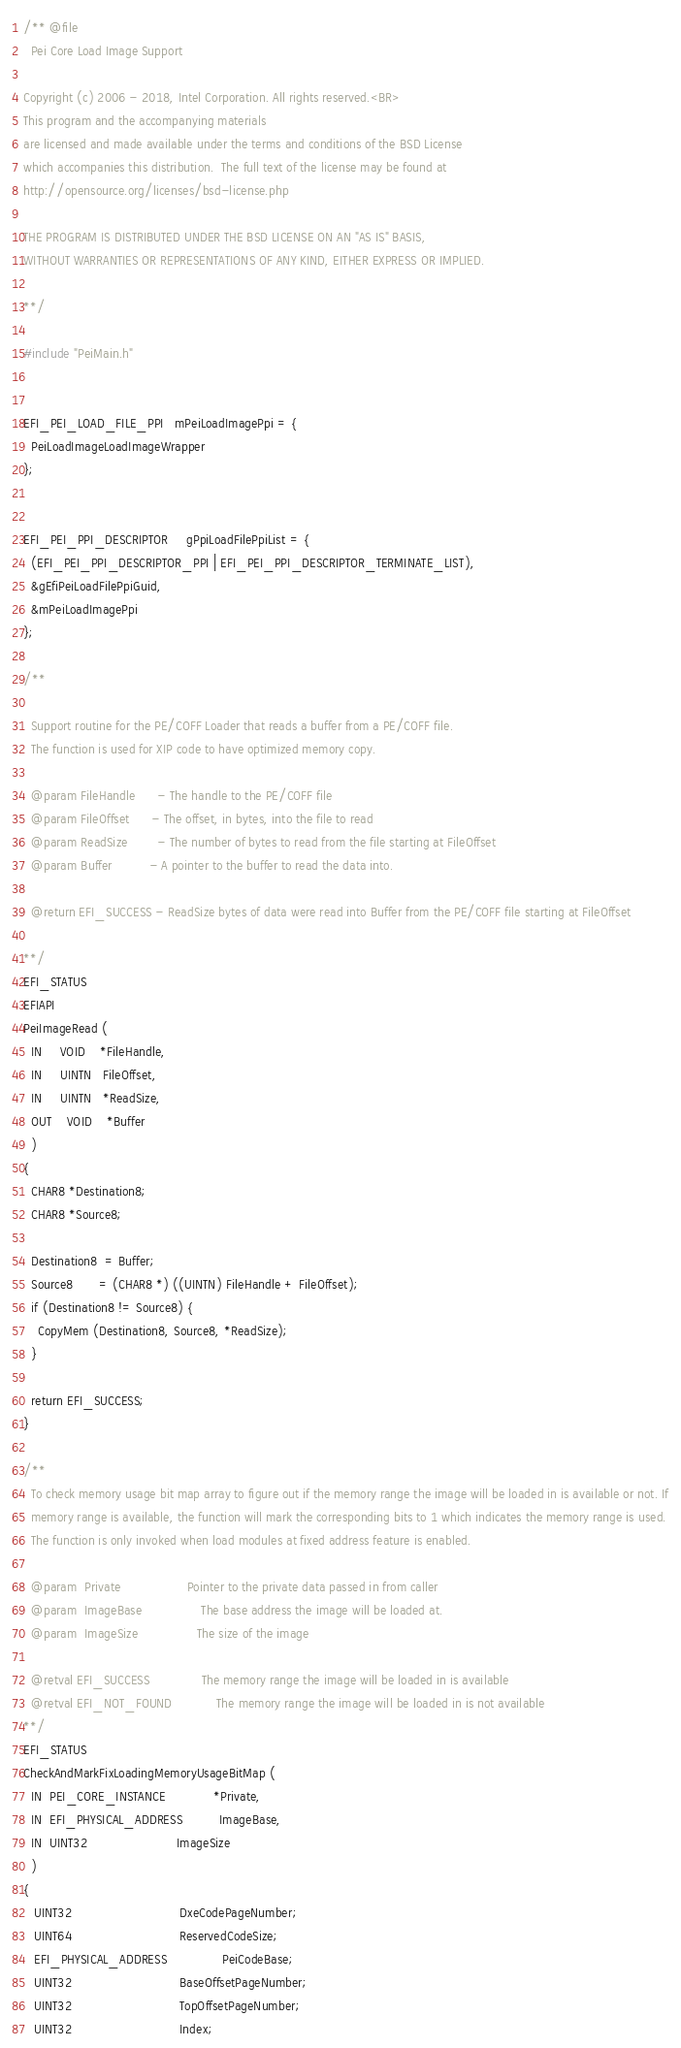Convert code to text. <code><loc_0><loc_0><loc_500><loc_500><_C_>/** @file
  Pei Core Load Image Support

Copyright (c) 2006 - 2018, Intel Corporation. All rights reserved.<BR>
This program and the accompanying materials
are licensed and made available under the terms and conditions of the BSD License
which accompanies this distribution.  The full text of the license may be found at
http://opensource.org/licenses/bsd-license.php

THE PROGRAM IS DISTRIBUTED UNDER THE BSD LICENSE ON AN "AS IS" BASIS,
WITHOUT WARRANTIES OR REPRESENTATIONS OF ANY KIND, EITHER EXPRESS OR IMPLIED.

**/

#include "PeiMain.h"


EFI_PEI_LOAD_FILE_PPI   mPeiLoadImagePpi = {
  PeiLoadImageLoadImageWrapper
};


EFI_PEI_PPI_DESCRIPTOR     gPpiLoadFilePpiList = {
  (EFI_PEI_PPI_DESCRIPTOR_PPI | EFI_PEI_PPI_DESCRIPTOR_TERMINATE_LIST),
  &gEfiPeiLoadFilePpiGuid,
  &mPeiLoadImagePpi
};

/**

  Support routine for the PE/COFF Loader that reads a buffer from a PE/COFF file.
  The function is used for XIP code to have optimized memory copy.

  @param FileHandle      - The handle to the PE/COFF file
  @param FileOffset      - The offset, in bytes, into the file to read
  @param ReadSize        - The number of bytes to read from the file starting at FileOffset
  @param Buffer          - A pointer to the buffer to read the data into.

  @return EFI_SUCCESS - ReadSize bytes of data were read into Buffer from the PE/COFF file starting at FileOffset

**/
EFI_STATUS
EFIAPI
PeiImageRead (
  IN     VOID    *FileHandle,
  IN     UINTN   FileOffset,
  IN     UINTN   *ReadSize,
  OUT    VOID    *Buffer
  )
{
  CHAR8 *Destination8;
  CHAR8 *Source8;

  Destination8  = Buffer;
  Source8       = (CHAR8 *) ((UINTN) FileHandle + FileOffset);
  if (Destination8 != Source8) {
    CopyMem (Destination8, Source8, *ReadSize);
  }

  return EFI_SUCCESS;
}

/**
  To check memory usage bit map array to figure out if the memory range the image will be loaded in is available or not. If
  memory range is available, the function will mark the corresponding bits to 1 which indicates the memory range is used.
  The function is only invoked when load modules at fixed address feature is enabled.

  @param  Private                  Pointer to the private data passed in from caller
  @param  ImageBase                The base address the image will be loaded at.
  @param  ImageSize                The size of the image

  @retval EFI_SUCCESS              The memory range the image will be loaded in is available
  @retval EFI_NOT_FOUND            The memory range the image will be loaded in is not available
**/
EFI_STATUS
CheckAndMarkFixLoadingMemoryUsageBitMap (
  IN  PEI_CORE_INSTANCE             *Private,
  IN  EFI_PHYSICAL_ADDRESS          ImageBase,
  IN  UINT32                        ImageSize
  )
{
   UINT32                             DxeCodePageNumber;
   UINT64                             ReservedCodeSize;
   EFI_PHYSICAL_ADDRESS               PeiCodeBase;
   UINT32                             BaseOffsetPageNumber;
   UINT32                             TopOffsetPageNumber;
   UINT32                             Index;</code> 